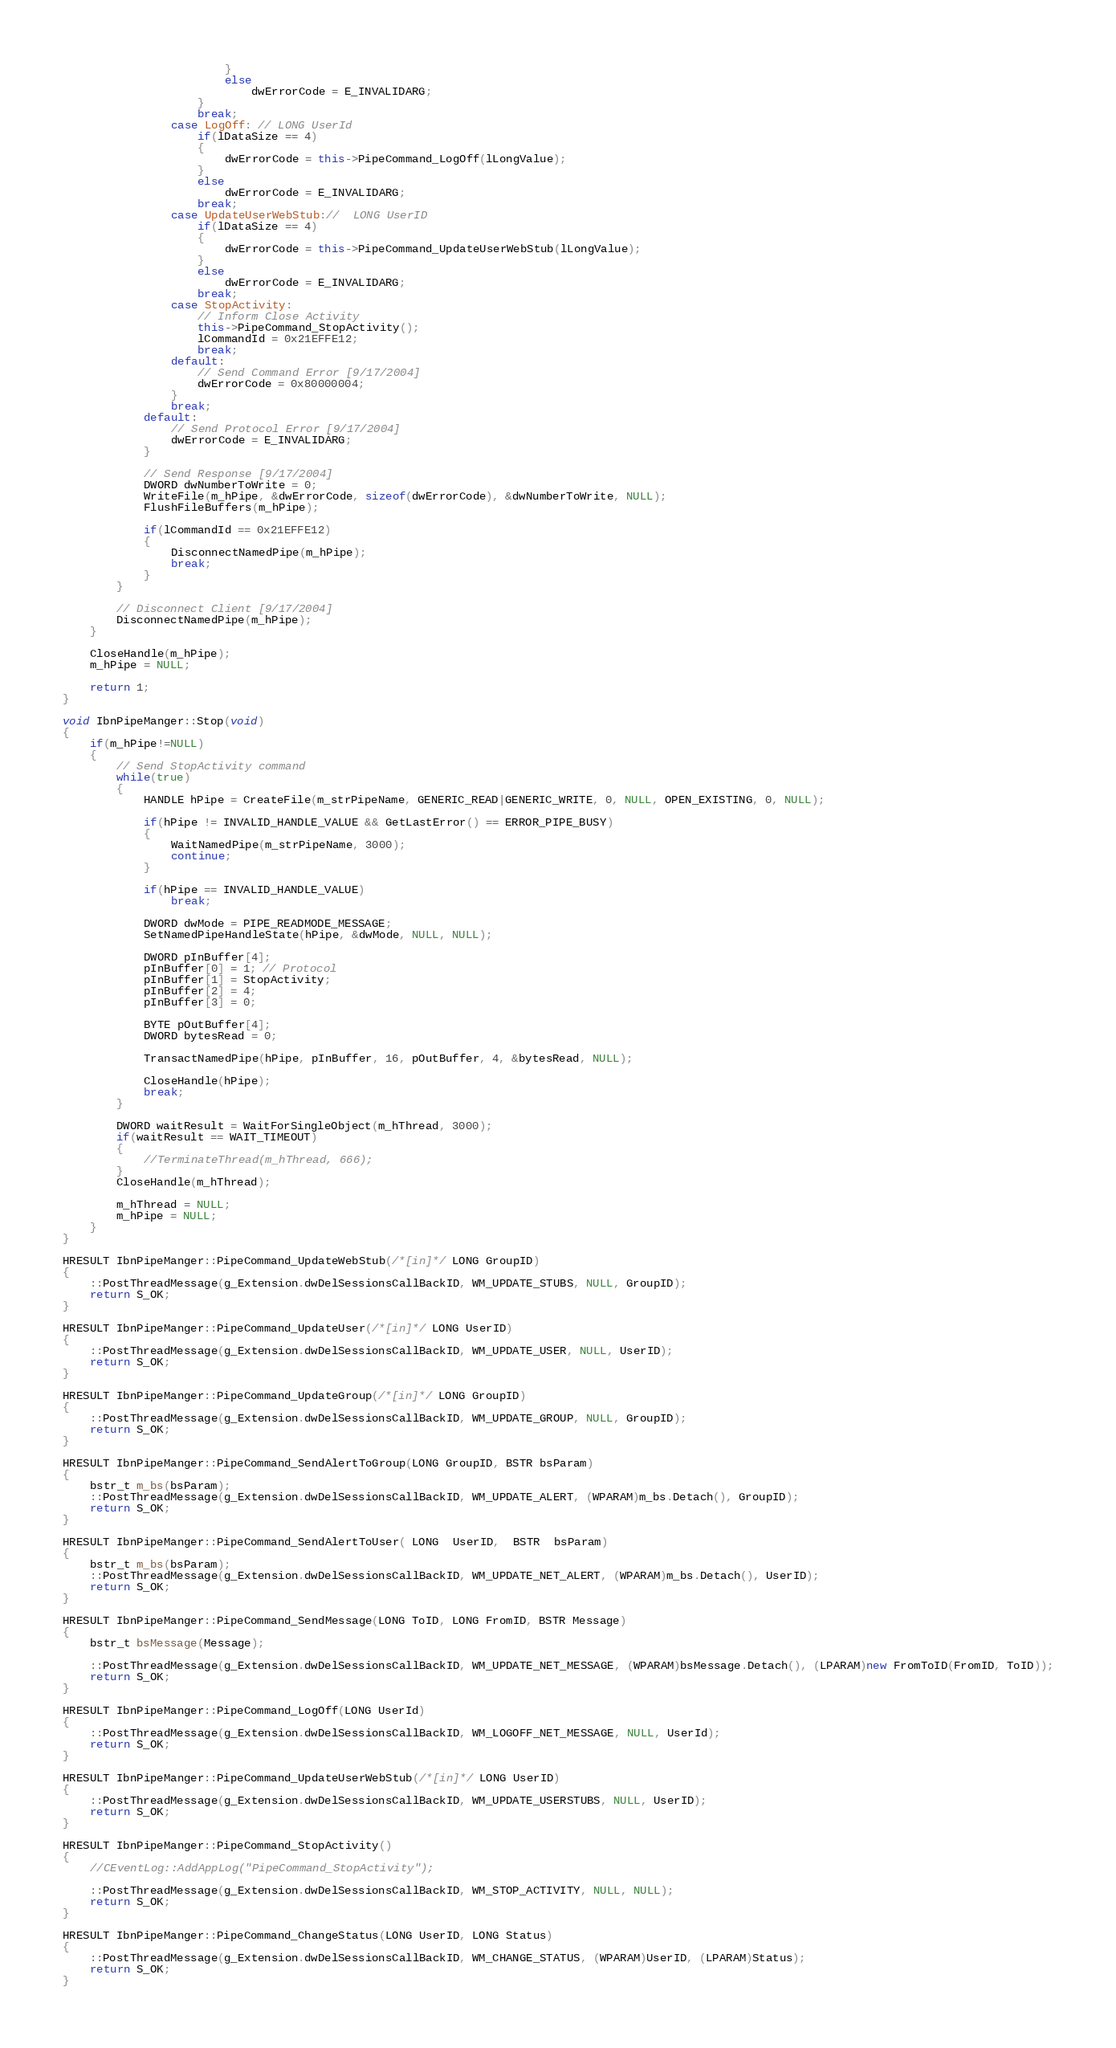Convert code to text. <code><loc_0><loc_0><loc_500><loc_500><_C++_>						}
						else
							dwErrorCode = E_INVALIDARG;
					}
					break;
				case LogOff: // LONG UserId
					if(lDataSize == 4)
					{
						dwErrorCode = this->PipeCommand_LogOff(lLongValue);
					}
					else
						dwErrorCode = E_INVALIDARG;
					break;
				case UpdateUserWebStub://	LONG UserID
					if(lDataSize == 4)
					{
						dwErrorCode = this->PipeCommand_UpdateUserWebStub(lLongValue);
					}
					else
						dwErrorCode = E_INVALIDARG;
					break;
				case StopActivity:
					// Inform Close Activity
					this->PipeCommand_StopActivity();
					lCommandId = 0x21EFFE12;
					break;
				default:
					// Send Command Error [9/17/2004]
					dwErrorCode = 0x80000004;
				}
				break;
			default:
				// Send Protocol Error [9/17/2004]
				dwErrorCode = E_INVALIDARG;
			}

			// Send Response [9/17/2004]
			DWORD dwNumberToWrite = 0;
			WriteFile(m_hPipe, &dwErrorCode, sizeof(dwErrorCode), &dwNumberToWrite, NULL);
			FlushFileBuffers(m_hPipe);

			if(lCommandId == 0x21EFFE12)
			{
				DisconnectNamedPipe(m_hPipe);
				break;
			}
		}

		// Disconnect Client [9/17/2004]
		DisconnectNamedPipe(m_hPipe);
	}

	CloseHandle(m_hPipe);
	m_hPipe = NULL;

	return 1;
}

void IbnPipeManger::Stop(void)
{
	if(m_hPipe!=NULL)
	{
		// Send StopActivity command
		while(true)
		{
			HANDLE hPipe = CreateFile(m_strPipeName, GENERIC_READ|GENERIC_WRITE, 0, NULL, OPEN_EXISTING, 0, NULL);

			if(hPipe != INVALID_HANDLE_VALUE && GetLastError() == ERROR_PIPE_BUSY)
			{
				WaitNamedPipe(m_strPipeName, 3000);
				continue;
			}

			if(hPipe == INVALID_HANDLE_VALUE)
				break;

			DWORD dwMode = PIPE_READMODE_MESSAGE;
			SetNamedPipeHandleState(hPipe, &dwMode, NULL, NULL);

			DWORD pInBuffer[4];
			pInBuffer[0] = 1; // Protocol
			pInBuffer[1] = StopActivity;
			pInBuffer[2] = 4;
			pInBuffer[3] = 0;

			BYTE pOutBuffer[4];
			DWORD bytesRead = 0;

			TransactNamedPipe(hPipe, pInBuffer, 16, pOutBuffer, 4, &bytesRead, NULL);

			CloseHandle(hPipe);
			break;
		}

		DWORD waitResult = WaitForSingleObject(m_hThread, 3000);
		if(waitResult == WAIT_TIMEOUT)
		{
			//TerminateThread(m_hThread, 666);
		}
		CloseHandle(m_hThread);

		m_hThread = NULL;
		m_hPipe = NULL;
	}
}

HRESULT IbnPipeManger::PipeCommand_UpdateWebStub(/*[in]*/ LONG GroupID)
{
	::PostThreadMessage(g_Extension.dwDelSessionsCallBackID, WM_UPDATE_STUBS, NULL, GroupID);
	return S_OK;
}

HRESULT IbnPipeManger::PipeCommand_UpdateUser(/*[in]*/ LONG UserID)
{
	::PostThreadMessage(g_Extension.dwDelSessionsCallBackID, WM_UPDATE_USER, NULL, UserID);
	return S_OK;
}

HRESULT IbnPipeManger::PipeCommand_UpdateGroup(/*[in]*/ LONG GroupID)
{
	::PostThreadMessage(g_Extension.dwDelSessionsCallBackID, WM_UPDATE_GROUP, NULL, GroupID);
	return S_OK;
}

HRESULT IbnPipeManger::PipeCommand_SendAlertToGroup(LONG GroupID, BSTR bsParam)
{
	bstr_t m_bs(bsParam);
	::PostThreadMessage(g_Extension.dwDelSessionsCallBackID, WM_UPDATE_ALERT, (WPARAM)m_bs.Detach(), GroupID);
	return S_OK;
}

HRESULT IbnPipeManger::PipeCommand_SendAlertToUser( LONG  UserID,  BSTR  bsParam)
{
	bstr_t m_bs(bsParam);
	::PostThreadMessage(g_Extension.dwDelSessionsCallBackID, WM_UPDATE_NET_ALERT, (WPARAM)m_bs.Detach(), UserID);
	return S_OK;
}

HRESULT IbnPipeManger::PipeCommand_SendMessage(LONG ToID, LONG FromID, BSTR Message)
{
	bstr_t bsMessage(Message);

	::PostThreadMessage(g_Extension.dwDelSessionsCallBackID, WM_UPDATE_NET_MESSAGE, (WPARAM)bsMessage.Detach(), (LPARAM)new FromToID(FromID, ToID));
	return S_OK;
}

HRESULT IbnPipeManger::PipeCommand_LogOff(LONG UserId)
{
	::PostThreadMessage(g_Extension.dwDelSessionsCallBackID, WM_LOGOFF_NET_MESSAGE, NULL, UserId);
	return S_OK;
}

HRESULT IbnPipeManger::PipeCommand_UpdateUserWebStub(/*[in]*/ LONG UserID)
{
	::PostThreadMessage(g_Extension.dwDelSessionsCallBackID, WM_UPDATE_USERSTUBS, NULL, UserID);
	return S_OK;
}

HRESULT IbnPipeManger::PipeCommand_StopActivity()
{
	//CEventLog::AddAppLog("PipeCommand_StopActivity");

	::PostThreadMessage(g_Extension.dwDelSessionsCallBackID, WM_STOP_ACTIVITY, NULL, NULL);
	return S_OK;
}

HRESULT IbnPipeManger::PipeCommand_ChangeStatus(LONG UserID, LONG Status)
{
	::PostThreadMessage(g_Extension.dwDelSessionsCallBackID, WM_CHANGE_STATUS, (WPARAM)UserID, (LPARAM)Status);
	return S_OK;
}
</code> 